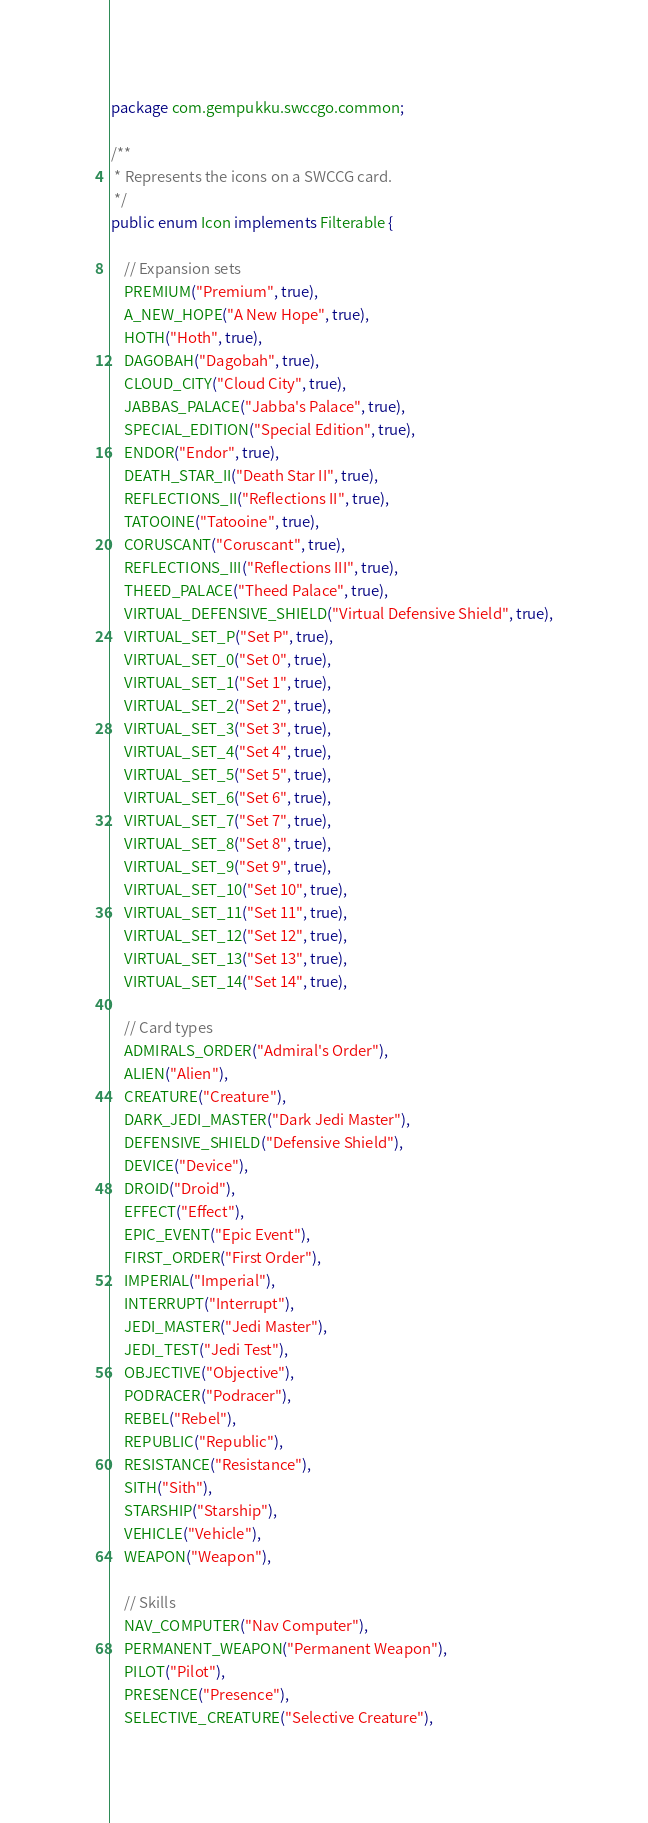<code> <loc_0><loc_0><loc_500><loc_500><_Java_>package com.gempukku.swccgo.common;

/**
 * Represents the icons on a SWCCG card.
 */
public enum Icon implements Filterable {

    // Expansion sets
    PREMIUM("Premium", true),
    A_NEW_HOPE("A New Hope", true),
    HOTH("Hoth", true),
    DAGOBAH("Dagobah", true),
    CLOUD_CITY("Cloud City", true),
    JABBAS_PALACE("Jabba's Palace", true),
    SPECIAL_EDITION("Special Edition", true),
    ENDOR("Endor", true),
    DEATH_STAR_II("Death Star II", true),
    REFLECTIONS_II("Reflections II", true),
    TATOOINE("Tatooine", true),
    CORUSCANT("Coruscant", true),
    REFLECTIONS_III("Reflections III", true),
    THEED_PALACE("Theed Palace", true),
    VIRTUAL_DEFENSIVE_SHIELD("Virtual Defensive Shield", true),
    VIRTUAL_SET_P("Set P", true),
    VIRTUAL_SET_0("Set 0", true),
    VIRTUAL_SET_1("Set 1", true),
    VIRTUAL_SET_2("Set 2", true),
    VIRTUAL_SET_3("Set 3", true),
    VIRTUAL_SET_4("Set 4", true),
    VIRTUAL_SET_5("Set 5", true),
    VIRTUAL_SET_6("Set 6", true),
    VIRTUAL_SET_7("Set 7", true),
    VIRTUAL_SET_8("Set 8", true),
    VIRTUAL_SET_9("Set 9", true),
    VIRTUAL_SET_10("Set 10", true),
    VIRTUAL_SET_11("Set 11", true),
    VIRTUAL_SET_12("Set 12", true),
    VIRTUAL_SET_13("Set 13", true),
    VIRTUAL_SET_14("Set 14", true),

    // Card types
    ADMIRALS_ORDER("Admiral's Order"),
    ALIEN("Alien"),
    CREATURE("Creature"),
    DARK_JEDI_MASTER("Dark Jedi Master"),
    DEFENSIVE_SHIELD("Defensive Shield"),
    DEVICE("Device"),
    DROID("Droid"),
    EFFECT("Effect"),
    EPIC_EVENT("Epic Event"),
    FIRST_ORDER("First Order"),
    IMPERIAL("Imperial"),
    INTERRUPT("Interrupt"),
    JEDI_MASTER("Jedi Master"),
    JEDI_TEST("Jedi Test"),
    OBJECTIVE("Objective"),
    PODRACER("Podracer"),
    REBEL("Rebel"),
    REPUBLIC("Republic"),
    RESISTANCE("Resistance"),
    SITH("Sith"),
    STARSHIP("Starship"),
    VEHICLE("Vehicle"),
    WEAPON("Weapon"),

    // Skills
    NAV_COMPUTER("Nav Computer"),
    PERMANENT_WEAPON("Permanent Weapon"),
    PILOT("Pilot"),
    PRESENCE("Presence"),
    SELECTIVE_CREATURE("Selective Creature"),</code> 